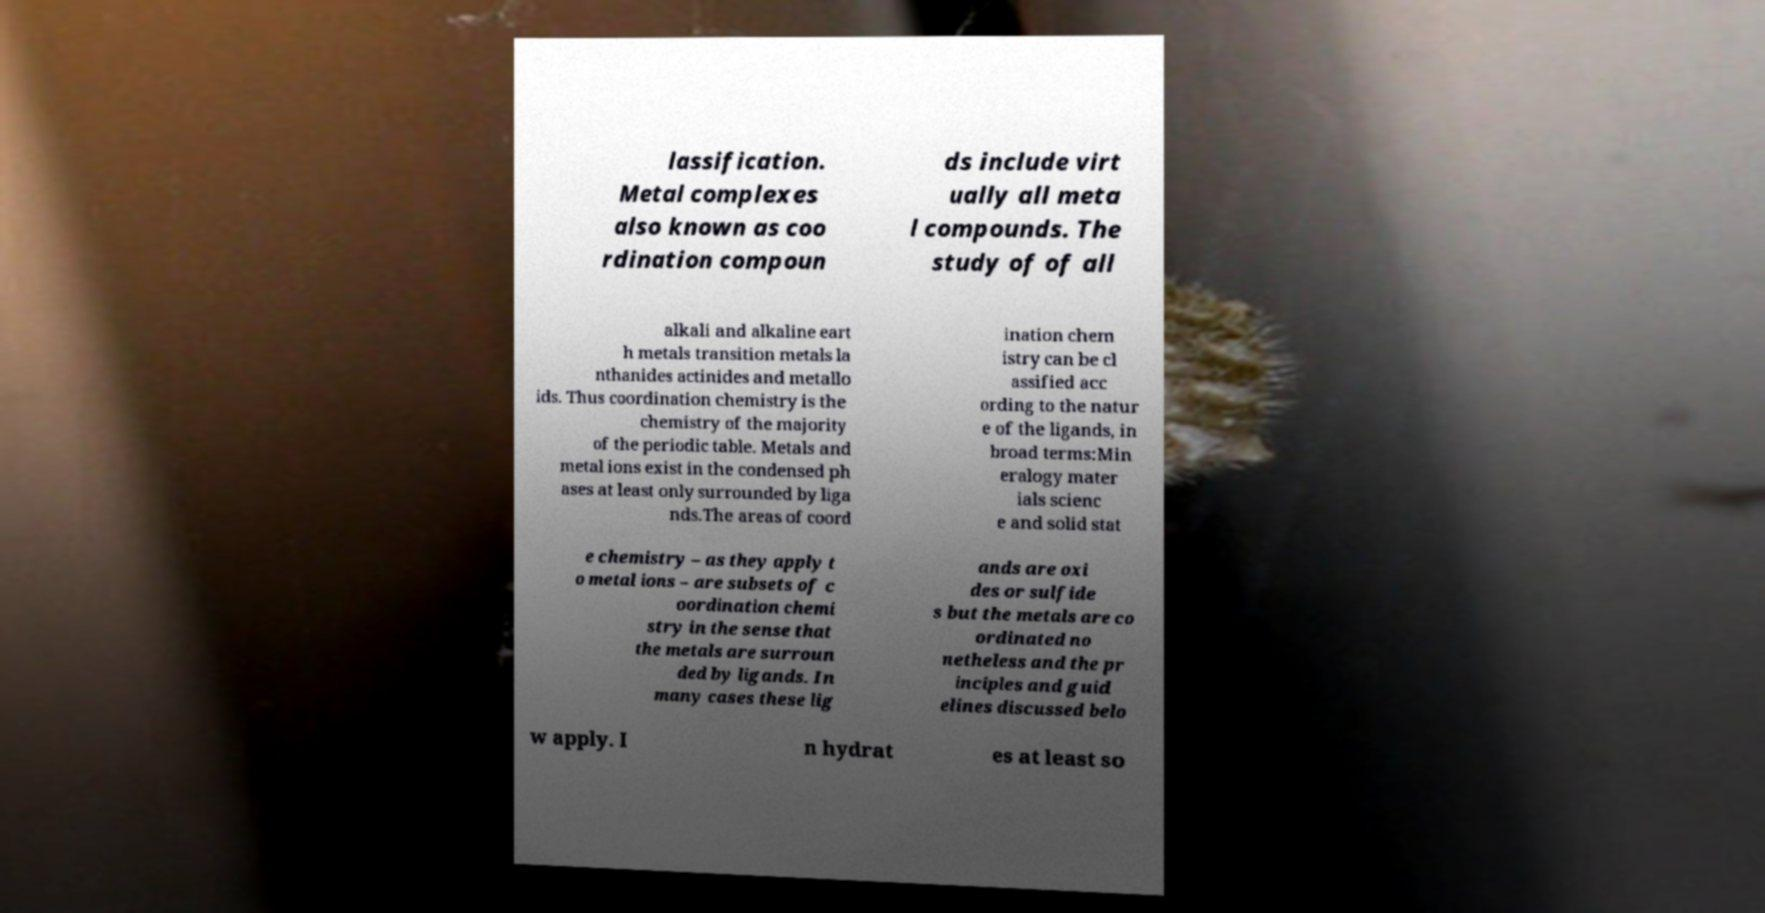Can you read and provide the text displayed in the image?This photo seems to have some interesting text. Can you extract and type it out for me? lassification. Metal complexes also known as coo rdination compoun ds include virt ually all meta l compounds. The study of of all alkali and alkaline eart h metals transition metals la nthanides actinides and metallo ids. Thus coordination chemistry is the chemistry of the majority of the periodic table. Metals and metal ions exist in the condensed ph ases at least only surrounded by liga nds.The areas of coord ination chem istry can be cl assified acc ording to the natur e of the ligands, in broad terms:Min eralogy mater ials scienc e and solid stat e chemistry – as they apply t o metal ions – are subsets of c oordination chemi stry in the sense that the metals are surroun ded by ligands. In many cases these lig ands are oxi des or sulfide s but the metals are co ordinated no netheless and the pr inciples and guid elines discussed belo w apply. I n hydrat es at least so 